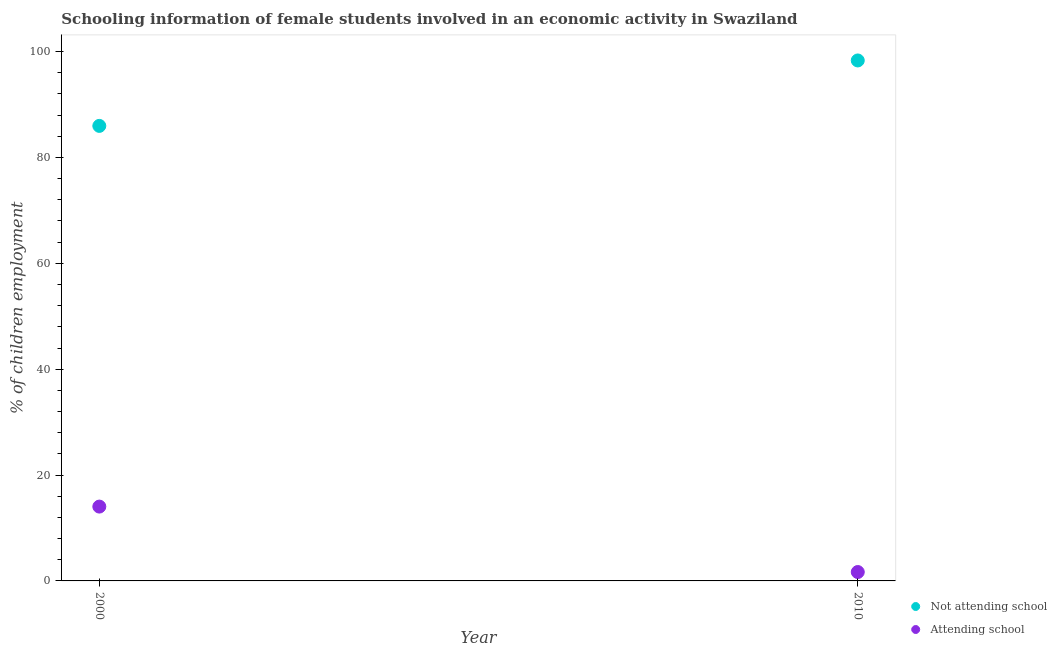Is the number of dotlines equal to the number of legend labels?
Your response must be concise. Yes. What is the percentage of employed females who are not attending school in 2010?
Provide a succinct answer. 98.32. Across all years, what is the maximum percentage of employed females who are not attending school?
Make the answer very short. 98.32. Across all years, what is the minimum percentage of employed females who are attending school?
Make the answer very short. 1.68. In which year was the percentage of employed females who are attending school minimum?
Keep it short and to the point. 2010. What is the total percentage of employed females who are not attending school in the graph?
Provide a succinct answer. 184.28. What is the difference between the percentage of employed females who are attending school in 2000 and that in 2010?
Provide a succinct answer. 12.36. What is the difference between the percentage of employed females who are attending school in 2010 and the percentage of employed females who are not attending school in 2000?
Keep it short and to the point. -84.28. What is the average percentage of employed females who are not attending school per year?
Offer a very short reply. 92.14. In the year 2000, what is the difference between the percentage of employed females who are attending school and percentage of employed females who are not attending school?
Your answer should be very brief. -71.92. What is the ratio of the percentage of employed females who are not attending school in 2000 to that in 2010?
Your response must be concise. 0.87. Does the percentage of employed females who are attending school monotonically increase over the years?
Ensure brevity in your answer.  No. Is the percentage of employed females who are not attending school strictly less than the percentage of employed females who are attending school over the years?
Provide a succinct answer. No. How many years are there in the graph?
Make the answer very short. 2. What is the difference between two consecutive major ticks on the Y-axis?
Offer a terse response. 20. Does the graph contain grids?
Your answer should be very brief. No. Where does the legend appear in the graph?
Provide a succinct answer. Bottom right. What is the title of the graph?
Provide a succinct answer. Schooling information of female students involved in an economic activity in Swaziland. Does "Techinal cooperation" appear as one of the legend labels in the graph?
Your answer should be compact. No. What is the label or title of the Y-axis?
Keep it short and to the point. % of children employment. What is the % of children employment in Not attending school in 2000?
Give a very brief answer. 85.96. What is the % of children employment in Attending school in 2000?
Your answer should be compact. 14.04. What is the % of children employment of Not attending school in 2010?
Keep it short and to the point. 98.32. What is the % of children employment of Attending school in 2010?
Provide a succinct answer. 1.68. Across all years, what is the maximum % of children employment in Not attending school?
Ensure brevity in your answer.  98.32. Across all years, what is the maximum % of children employment in Attending school?
Make the answer very short. 14.04. Across all years, what is the minimum % of children employment in Not attending school?
Your answer should be compact. 85.96. Across all years, what is the minimum % of children employment in Attending school?
Make the answer very short. 1.68. What is the total % of children employment in Not attending school in the graph?
Your answer should be very brief. 184.28. What is the total % of children employment of Attending school in the graph?
Provide a succinct answer. 15.72. What is the difference between the % of children employment of Not attending school in 2000 and that in 2010?
Your answer should be very brief. -12.36. What is the difference between the % of children employment of Attending school in 2000 and that in 2010?
Your answer should be compact. 12.36. What is the difference between the % of children employment in Not attending school in 2000 and the % of children employment in Attending school in 2010?
Give a very brief answer. 84.28. What is the average % of children employment in Not attending school per year?
Keep it short and to the point. 92.14. What is the average % of children employment of Attending school per year?
Provide a short and direct response. 7.86. In the year 2000, what is the difference between the % of children employment in Not attending school and % of children employment in Attending school?
Your answer should be compact. 71.92. In the year 2010, what is the difference between the % of children employment of Not attending school and % of children employment of Attending school?
Make the answer very short. 96.64. What is the ratio of the % of children employment of Not attending school in 2000 to that in 2010?
Your response must be concise. 0.87. What is the ratio of the % of children employment in Attending school in 2000 to that in 2010?
Ensure brevity in your answer.  8.36. What is the difference between the highest and the second highest % of children employment of Not attending school?
Offer a very short reply. 12.36. What is the difference between the highest and the second highest % of children employment in Attending school?
Provide a succinct answer. 12.36. What is the difference between the highest and the lowest % of children employment in Not attending school?
Provide a short and direct response. 12.36. What is the difference between the highest and the lowest % of children employment of Attending school?
Keep it short and to the point. 12.36. 